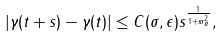<formula> <loc_0><loc_0><loc_500><loc_500>| \gamma ( t + s ) - \gamma ( t ) | \leq C ( \sigma , \epsilon ) s ^ { \frac { 1 } { 1 + m _ { \sigma } ^ { 2 } } } ,</formula> 